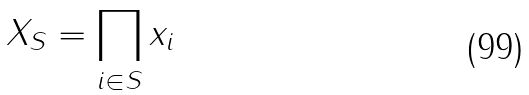<formula> <loc_0><loc_0><loc_500><loc_500>X _ { S } = \prod _ { i \in S } x _ { i }</formula> 